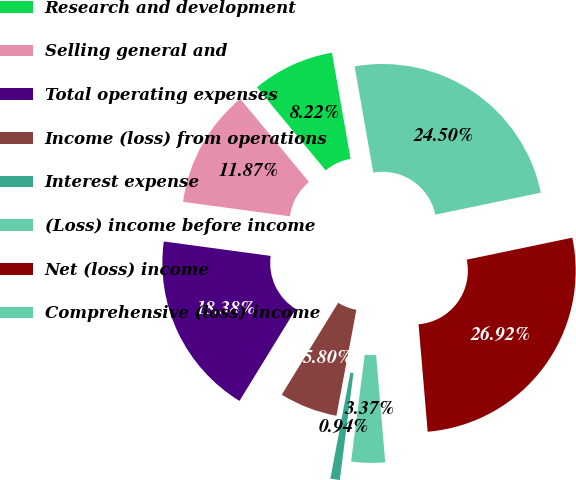Convert chart. <chart><loc_0><loc_0><loc_500><loc_500><pie_chart><fcel>Research and development<fcel>Selling general and<fcel>Total operating expenses<fcel>Income (loss) from operations<fcel>Interest expense<fcel>(Loss) income before income<fcel>Net (loss) income<fcel>Comprehensive (loss) income<nl><fcel>8.22%<fcel>11.87%<fcel>18.38%<fcel>5.8%<fcel>0.94%<fcel>3.37%<fcel>26.92%<fcel>24.5%<nl></chart> 